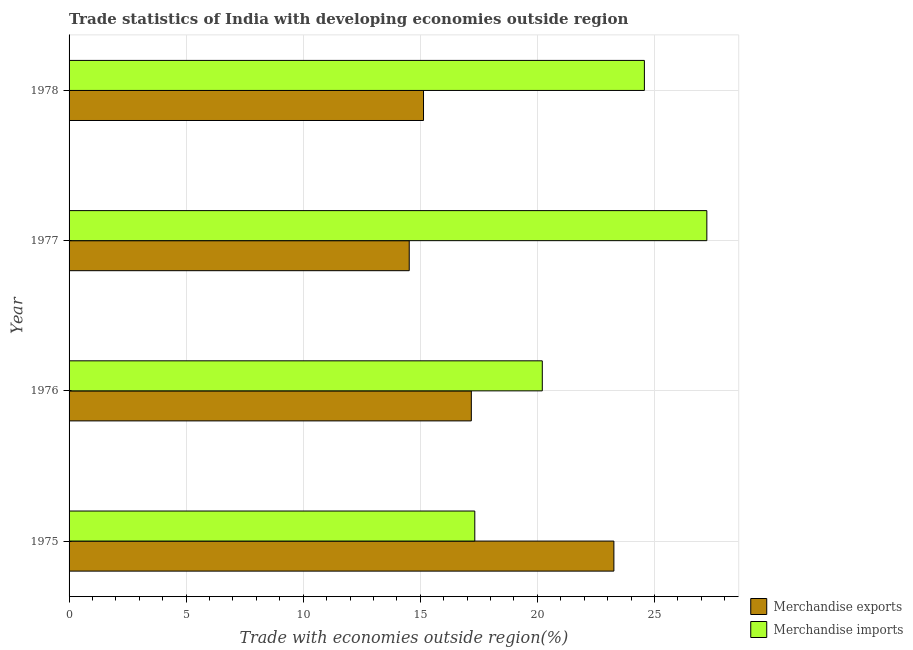How many different coloured bars are there?
Your response must be concise. 2. How many groups of bars are there?
Your answer should be compact. 4. Are the number of bars per tick equal to the number of legend labels?
Keep it short and to the point. Yes. How many bars are there on the 1st tick from the top?
Give a very brief answer. 2. In how many cases, is the number of bars for a given year not equal to the number of legend labels?
Provide a short and direct response. 0. What is the merchandise exports in 1976?
Your response must be concise. 17.18. Across all years, what is the maximum merchandise imports?
Make the answer very short. 27.24. Across all years, what is the minimum merchandise imports?
Give a very brief answer. 17.33. In which year was the merchandise exports maximum?
Make the answer very short. 1975. In which year was the merchandise imports minimum?
Your answer should be very brief. 1975. What is the total merchandise exports in the graph?
Your answer should be very brief. 70.11. What is the difference between the merchandise exports in 1975 and that in 1978?
Provide a short and direct response. 8.13. What is the difference between the merchandise imports in 1976 and the merchandise exports in 1978?
Your answer should be very brief. 5.07. What is the average merchandise imports per year?
Your response must be concise. 22.34. In the year 1975, what is the difference between the merchandise exports and merchandise imports?
Offer a terse response. 5.94. Is the merchandise exports in 1975 less than that in 1976?
Your response must be concise. No. Is the difference between the merchandise exports in 1975 and 1977 greater than the difference between the merchandise imports in 1975 and 1977?
Make the answer very short. Yes. What is the difference between the highest and the second highest merchandise exports?
Your answer should be compact. 6.09. What is the difference between the highest and the lowest merchandise exports?
Provide a succinct answer. 8.74. What does the 1st bar from the top in 1978 represents?
Offer a terse response. Merchandise imports. What does the 2nd bar from the bottom in 1976 represents?
Your answer should be compact. Merchandise imports. Are all the bars in the graph horizontal?
Your answer should be very brief. Yes. What is the difference between two consecutive major ticks on the X-axis?
Your answer should be compact. 5. Does the graph contain any zero values?
Offer a terse response. No. Does the graph contain grids?
Offer a terse response. Yes. Where does the legend appear in the graph?
Your answer should be very brief. Bottom right. What is the title of the graph?
Keep it short and to the point. Trade statistics of India with developing economies outside region. Does "Exports of goods" appear as one of the legend labels in the graph?
Offer a very short reply. No. What is the label or title of the X-axis?
Offer a terse response. Trade with economies outside region(%). What is the label or title of the Y-axis?
Make the answer very short. Year. What is the Trade with economies outside region(%) of Merchandise exports in 1975?
Give a very brief answer. 23.27. What is the Trade with economies outside region(%) in Merchandise imports in 1975?
Provide a short and direct response. 17.33. What is the Trade with economies outside region(%) of Merchandise exports in 1976?
Offer a very short reply. 17.18. What is the Trade with economies outside region(%) in Merchandise imports in 1976?
Provide a succinct answer. 20.21. What is the Trade with economies outside region(%) of Merchandise exports in 1977?
Provide a short and direct response. 14.53. What is the Trade with economies outside region(%) in Merchandise imports in 1977?
Keep it short and to the point. 27.24. What is the Trade with economies outside region(%) of Merchandise exports in 1978?
Provide a succinct answer. 15.14. What is the Trade with economies outside region(%) in Merchandise imports in 1978?
Your answer should be very brief. 24.57. Across all years, what is the maximum Trade with economies outside region(%) of Merchandise exports?
Make the answer very short. 23.27. Across all years, what is the maximum Trade with economies outside region(%) in Merchandise imports?
Provide a short and direct response. 27.24. Across all years, what is the minimum Trade with economies outside region(%) in Merchandise exports?
Provide a succinct answer. 14.53. Across all years, what is the minimum Trade with economies outside region(%) of Merchandise imports?
Offer a very short reply. 17.33. What is the total Trade with economies outside region(%) of Merchandise exports in the graph?
Offer a terse response. 70.11. What is the total Trade with economies outside region(%) in Merchandise imports in the graph?
Give a very brief answer. 89.34. What is the difference between the Trade with economies outside region(%) of Merchandise exports in 1975 and that in 1976?
Your answer should be compact. 6.09. What is the difference between the Trade with economies outside region(%) in Merchandise imports in 1975 and that in 1976?
Ensure brevity in your answer.  -2.88. What is the difference between the Trade with economies outside region(%) of Merchandise exports in 1975 and that in 1977?
Your answer should be very brief. 8.74. What is the difference between the Trade with economies outside region(%) in Merchandise imports in 1975 and that in 1977?
Offer a terse response. -9.91. What is the difference between the Trade with economies outside region(%) of Merchandise exports in 1975 and that in 1978?
Keep it short and to the point. 8.13. What is the difference between the Trade with economies outside region(%) in Merchandise imports in 1975 and that in 1978?
Your answer should be very brief. -7.24. What is the difference between the Trade with economies outside region(%) of Merchandise exports in 1976 and that in 1977?
Ensure brevity in your answer.  2.65. What is the difference between the Trade with economies outside region(%) in Merchandise imports in 1976 and that in 1977?
Ensure brevity in your answer.  -7.03. What is the difference between the Trade with economies outside region(%) of Merchandise exports in 1976 and that in 1978?
Make the answer very short. 2.04. What is the difference between the Trade with economies outside region(%) in Merchandise imports in 1976 and that in 1978?
Your answer should be very brief. -4.36. What is the difference between the Trade with economies outside region(%) of Merchandise exports in 1977 and that in 1978?
Your answer should be very brief. -0.61. What is the difference between the Trade with economies outside region(%) in Merchandise imports in 1977 and that in 1978?
Keep it short and to the point. 2.67. What is the difference between the Trade with economies outside region(%) of Merchandise exports in 1975 and the Trade with economies outside region(%) of Merchandise imports in 1976?
Provide a succinct answer. 3.06. What is the difference between the Trade with economies outside region(%) in Merchandise exports in 1975 and the Trade with economies outside region(%) in Merchandise imports in 1977?
Offer a very short reply. -3.97. What is the difference between the Trade with economies outside region(%) of Merchandise exports in 1975 and the Trade with economies outside region(%) of Merchandise imports in 1978?
Your response must be concise. -1.3. What is the difference between the Trade with economies outside region(%) of Merchandise exports in 1976 and the Trade with economies outside region(%) of Merchandise imports in 1977?
Offer a very short reply. -10.06. What is the difference between the Trade with economies outside region(%) in Merchandise exports in 1976 and the Trade with economies outside region(%) in Merchandise imports in 1978?
Offer a very short reply. -7.39. What is the difference between the Trade with economies outside region(%) of Merchandise exports in 1977 and the Trade with economies outside region(%) of Merchandise imports in 1978?
Ensure brevity in your answer.  -10.04. What is the average Trade with economies outside region(%) of Merchandise exports per year?
Your answer should be compact. 17.53. What is the average Trade with economies outside region(%) in Merchandise imports per year?
Offer a very short reply. 22.34. In the year 1975, what is the difference between the Trade with economies outside region(%) in Merchandise exports and Trade with economies outside region(%) in Merchandise imports?
Your response must be concise. 5.94. In the year 1976, what is the difference between the Trade with economies outside region(%) of Merchandise exports and Trade with economies outside region(%) of Merchandise imports?
Offer a terse response. -3.03. In the year 1977, what is the difference between the Trade with economies outside region(%) in Merchandise exports and Trade with economies outside region(%) in Merchandise imports?
Your answer should be very brief. -12.71. In the year 1978, what is the difference between the Trade with economies outside region(%) of Merchandise exports and Trade with economies outside region(%) of Merchandise imports?
Your answer should be compact. -9.43. What is the ratio of the Trade with economies outside region(%) of Merchandise exports in 1975 to that in 1976?
Offer a very short reply. 1.35. What is the ratio of the Trade with economies outside region(%) of Merchandise imports in 1975 to that in 1976?
Provide a short and direct response. 0.86. What is the ratio of the Trade with economies outside region(%) in Merchandise exports in 1975 to that in 1977?
Offer a terse response. 1.6. What is the ratio of the Trade with economies outside region(%) in Merchandise imports in 1975 to that in 1977?
Offer a very short reply. 0.64. What is the ratio of the Trade with economies outside region(%) in Merchandise exports in 1975 to that in 1978?
Your answer should be very brief. 1.54. What is the ratio of the Trade with economies outside region(%) in Merchandise imports in 1975 to that in 1978?
Make the answer very short. 0.71. What is the ratio of the Trade with economies outside region(%) in Merchandise exports in 1976 to that in 1977?
Ensure brevity in your answer.  1.18. What is the ratio of the Trade with economies outside region(%) of Merchandise imports in 1976 to that in 1977?
Provide a succinct answer. 0.74. What is the ratio of the Trade with economies outside region(%) in Merchandise exports in 1976 to that in 1978?
Ensure brevity in your answer.  1.13. What is the ratio of the Trade with economies outside region(%) in Merchandise imports in 1976 to that in 1978?
Your response must be concise. 0.82. What is the ratio of the Trade with economies outside region(%) of Merchandise exports in 1977 to that in 1978?
Keep it short and to the point. 0.96. What is the ratio of the Trade with economies outside region(%) in Merchandise imports in 1977 to that in 1978?
Your response must be concise. 1.11. What is the difference between the highest and the second highest Trade with economies outside region(%) of Merchandise exports?
Keep it short and to the point. 6.09. What is the difference between the highest and the second highest Trade with economies outside region(%) of Merchandise imports?
Make the answer very short. 2.67. What is the difference between the highest and the lowest Trade with economies outside region(%) of Merchandise exports?
Keep it short and to the point. 8.74. What is the difference between the highest and the lowest Trade with economies outside region(%) of Merchandise imports?
Provide a succinct answer. 9.91. 